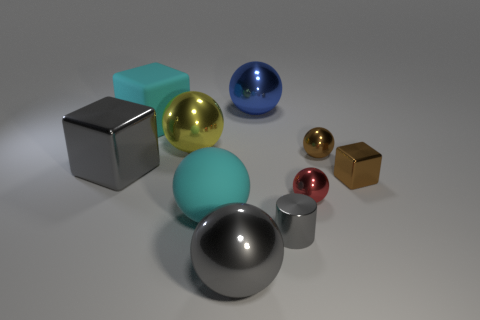Is the large metallic cube the same color as the cylinder?
Your answer should be compact. Yes. Is there a tiny cylinder that has the same color as the large metallic block?
Give a very brief answer. Yes. Is the number of tiny metal blocks that are in front of the small brown block the same as the number of large objects that are in front of the gray shiny cylinder?
Offer a very short reply. No. How many other things are the same material as the brown ball?
Your answer should be very brief. 7. How many large things are yellow balls or gray metal objects?
Keep it short and to the point. 3. Are there the same number of cyan spheres in front of the large shiny block and blue metallic balls?
Ensure brevity in your answer.  Yes. There is a gray metallic object to the left of the rubber ball; are there any large spheres that are behind it?
Give a very brief answer. Yes. What number of other objects are the same color as the tiny cylinder?
Keep it short and to the point. 2. The big rubber block has what color?
Your answer should be very brief. Cyan. What size is the gray object that is both on the right side of the cyan cube and on the left side of the gray metallic cylinder?
Ensure brevity in your answer.  Large. 